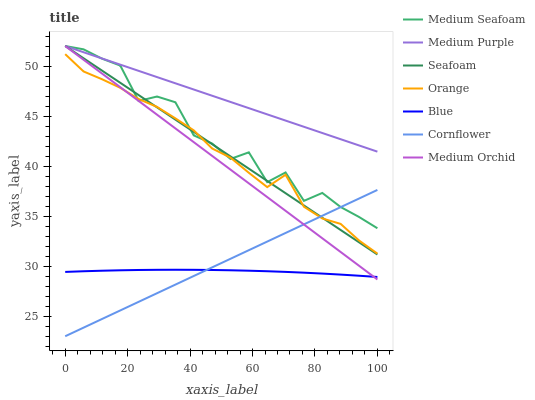Does Cornflower have the minimum area under the curve?
Answer yes or no. No. Does Cornflower have the maximum area under the curve?
Answer yes or no. No. Is Cornflower the smoothest?
Answer yes or no. No. Is Cornflower the roughest?
Answer yes or no. No. Does Medium Orchid have the lowest value?
Answer yes or no. No. Does Cornflower have the highest value?
Answer yes or no. No. Is Blue less than Seafoam?
Answer yes or no. Yes. Is Medium Purple greater than Orange?
Answer yes or no. Yes. Does Blue intersect Seafoam?
Answer yes or no. No. 